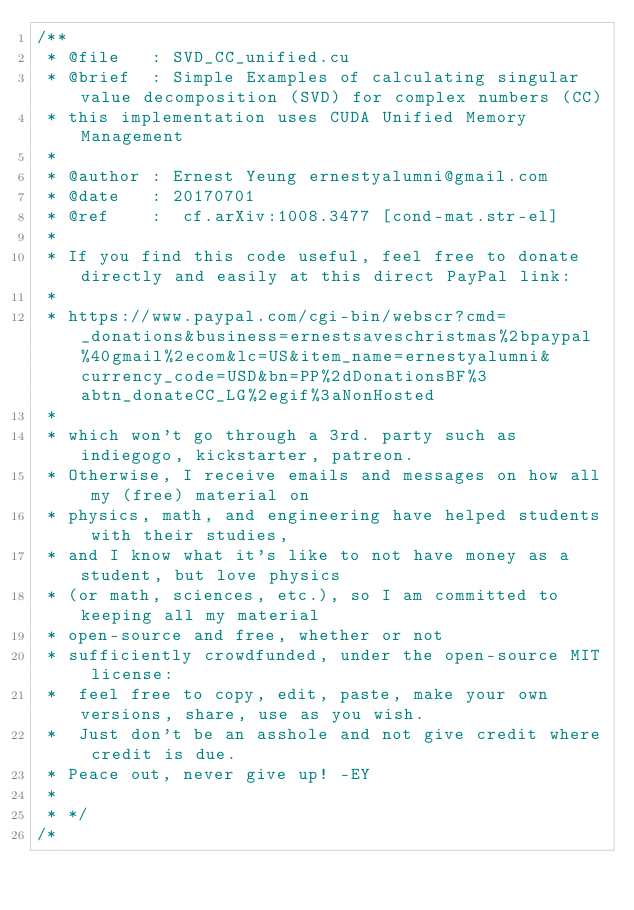<code> <loc_0><loc_0><loc_500><loc_500><_Cuda_>/**
 * @file   : SVD_CC_unified.cu
 * @brief  : Simple Examples of calculating singular value decomposition (SVD) for complex numbers (CC)  
 * this implementation uses CUDA Unified Memory Management
 *
 * @author : Ernest Yeung	ernestyalumni@gmail.com
 * @date   : 20170701
 * @ref    :  cf.arXiv:1008.3477 [cond-mat.str-el]
 * 
 * If you find this code useful, feel free to donate directly and easily at this direct PayPal link: 
 * 
 * https://www.paypal.com/cgi-bin/webscr?cmd=_donations&business=ernestsaveschristmas%2bpaypal%40gmail%2ecom&lc=US&item_name=ernestyalumni&currency_code=USD&bn=PP%2dDonationsBF%3abtn_donateCC_LG%2egif%3aNonHosted 
 * 
 * which won't go through a 3rd. party such as indiegogo, kickstarter, patreon.  
 * Otherwise, I receive emails and messages on how all my (free) material on 
 * physics, math, and engineering have helped students with their studies, 
 * and I know what it's like to not have money as a student, but love physics 
 * (or math, sciences, etc.), so I am committed to keeping all my material 
 * open-source and free, whether or not 
 * sufficiently crowdfunded, under the open-source MIT license: 
 * 	feel free to copy, edit, paste, make your own versions, share, use as you wish.  
 *  Just don't be an asshole and not give credit where credit is due.  
 * Peace out, never give up! -EY
 * 
 * */
/*</code> 